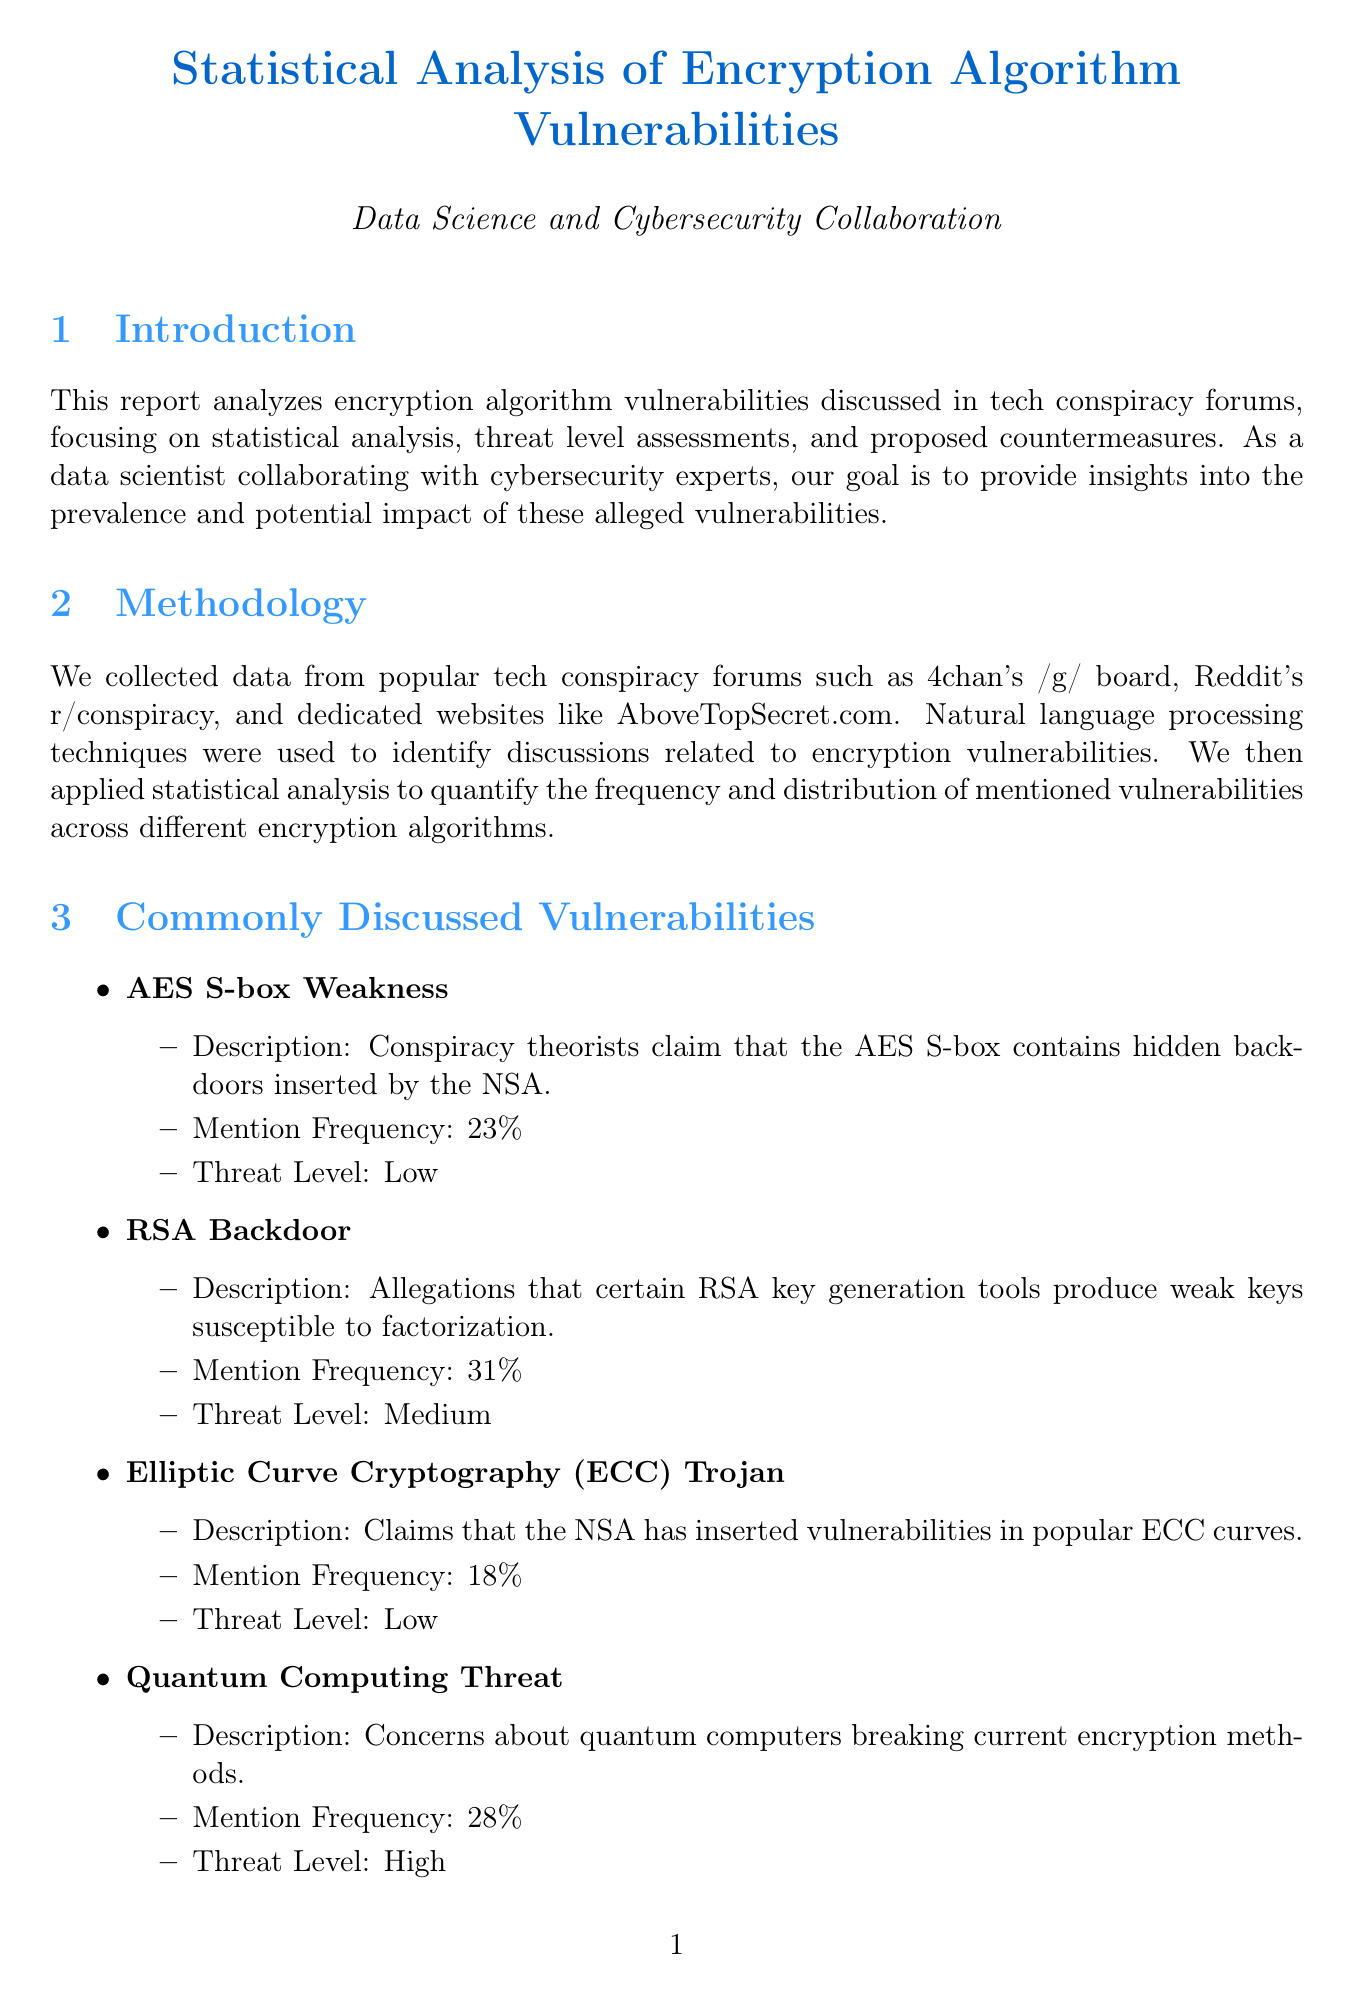What is the main focus of the report? The report analyzes encryption algorithm vulnerabilities, particularly discussing statistical analysis, threat level assessments, and proposed countermeasures.
Answer: encryption algorithm vulnerabilities What sources were used to collect data? The sources include popular tech conspiracy forums such as 4chan's /g/ board, Reddit's r/conspiracy, and AboveTopSecret.com.
Answer: tech conspiracy forums What is the threat level of the "Quantum Computing Threat"? The report categorizes the "Quantum Computing Threat" as a high-level threat based on the frequency of mentions in forums.
Answer: High What is the mention frequency of "RSA Backdoor"? The report states that the mention frequency of "RSA Backdoor" is calculated from the discussions analyzed across the forums.
Answer: 31% What statistical test was used in the analysis? Chi-square tests were employed to compare the distribution of vulnerabilities against a baseline of known vulnerabilities.
Answer: Chi-square tests Which organization is suggested for a public education campaign? The report proposes collaboration with an organization that focuses on civil liberties in the digital world.
Answer: Electronic Frontier Foundation How many commonly discussed vulnerabilities are listed in the report? The report details four alleged encryption vulnerabilities that are frequently discussed in tech conspiracy forums.
Answer: four What is proposed to accelerate research into quantum-resistant algorithms? The document suggests a collaboration with NIST and academic institutions for advancing research into these algorithms.
Answer: collaboration with NIST What machine learning algorithm was used for threat level assessment? The report specifies that Random Forest classifiers were used to assess the threat levels of the vulnerabilities discussed.
Answer: Random Forest classifiers 